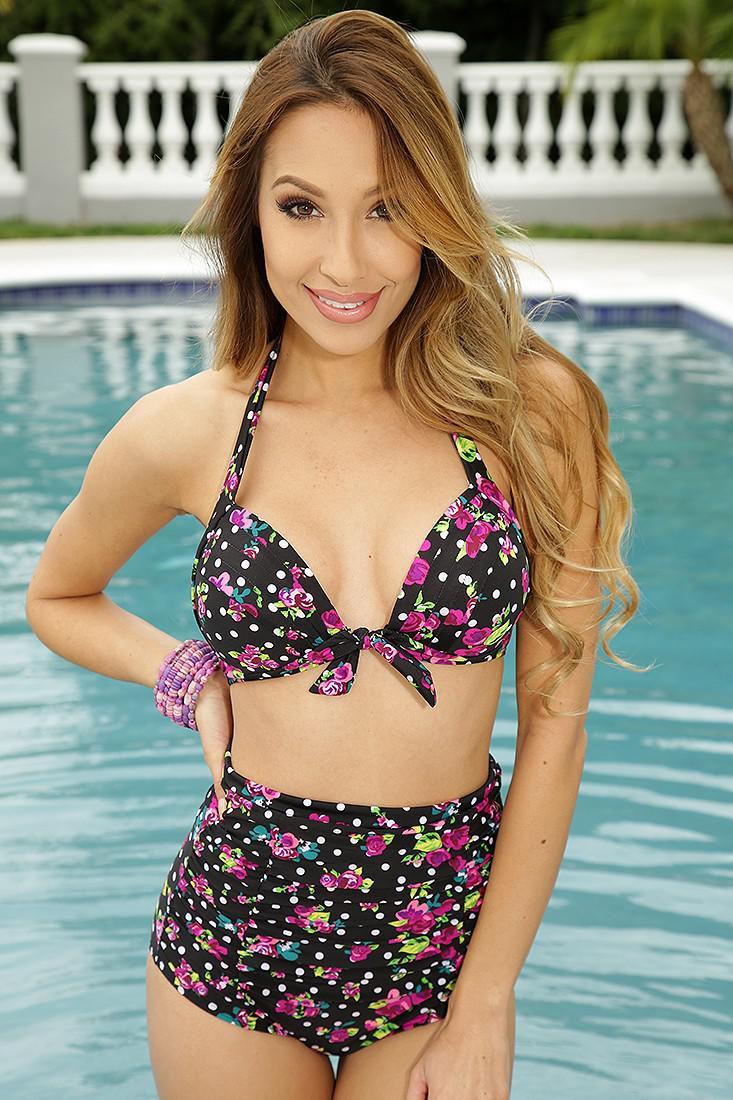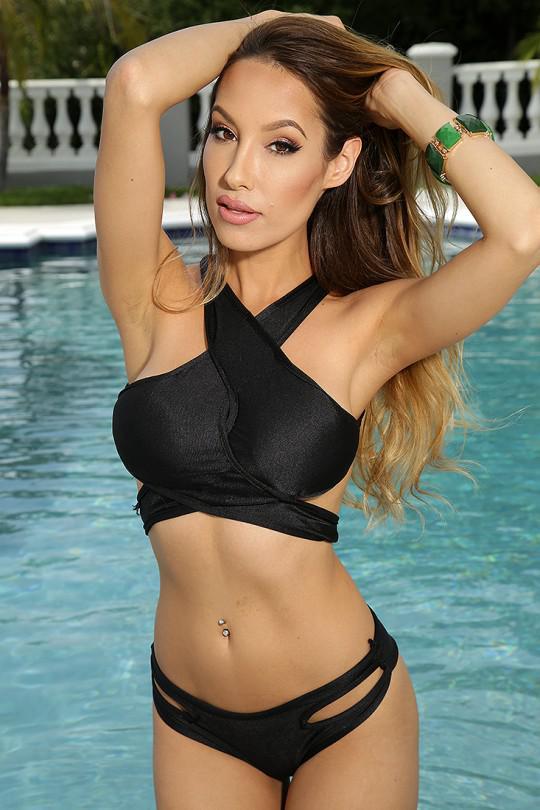The first image is the image on the left, the second image is the image on the right. Considering the images on both sides, is "You can see a swimming pool behind at least one of the models." valid? Answer yes or no. Yes. 